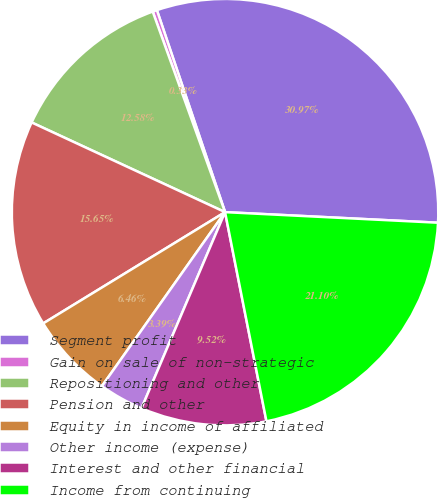<chart> <loc_0><loc_0><loc_500><loc_500><pie_chart><fcel>Segment profit<fcel>Gain on sale of non-strategic<fcel>Repositioning and other<fcel>Pension and other<fcel>Equity in income of affiliated<fcel>Other income (expense)<fcel>Interest and other financial<fcel>Income from continuing<nl><fcel>30.97%<fcel>0.33%<fcel>12.58%<fcel>15.65%<fcel>6.46%<fcel>3.39%<fcel>9.52%<fcel>21.1%<nl></chart> 